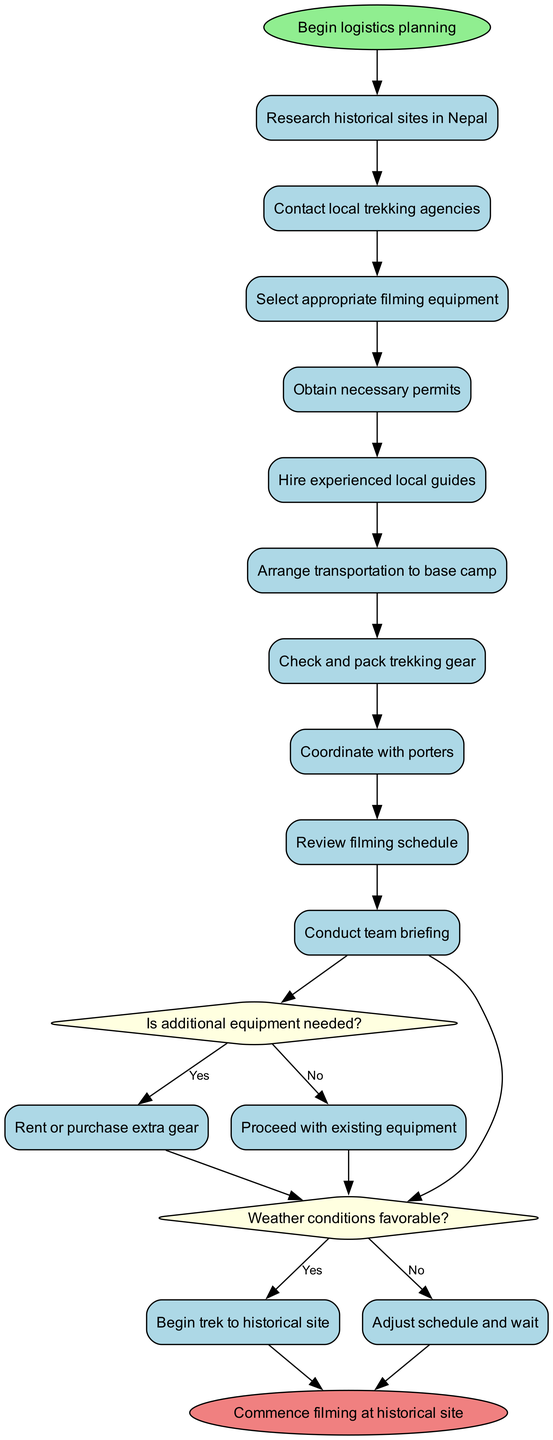What is the starting point of the logistics planning? The starting point is indicated as "Begin logistics planning" in the diagram.
Answer: Begin logistics planning How many main activities are listed in the diagram? The diagram lists 10 activities, which are indicated in the activities section provided.
Answer: 10 What decision needs to be made after packing trekking gear? The decision made after packing trekking gear is whether the weather conditions are favorable.
Answer: Weather conditions favorable? What happens if additional equipment is needed? If additional equipment is needed, the next step is to rent or purchase extra gear, as shown in the yes branch of the decision node.
Answer: Rent or purchase extra gear What is the final action in the activity diagram? The final action listed in the diagram is "Commence filming at historical site," which represents the end of the process.
Answer: Commence filming at historical site What activity follows the hiring of experienced local guides? After hiring experienced local guides, the next activity is to arrange transportation to base camp, as indicated by the flow of the diagram.
Answer: Arrange transportation to base camp What are the conditions under which the team will begin the trek to the historical site? The team will begin the trek if the weather conditions are favorable, which is a condition evaluated in the decision node.
Answer: Weather conditions favorable? How does the diagram handle unfavorable weather conditions? If the weather conditions are not favorable, the diagram indicates to "Adjust schedule and wait," as specified in the no branch of the decision node.
Answer: Adjust schedule and wait What is the role of local guides in the logistics plan? The local guides are hired as an essential step in the logistics plan to ensure smooth coordination during the trek.
Answer: Hire experienced local guides 